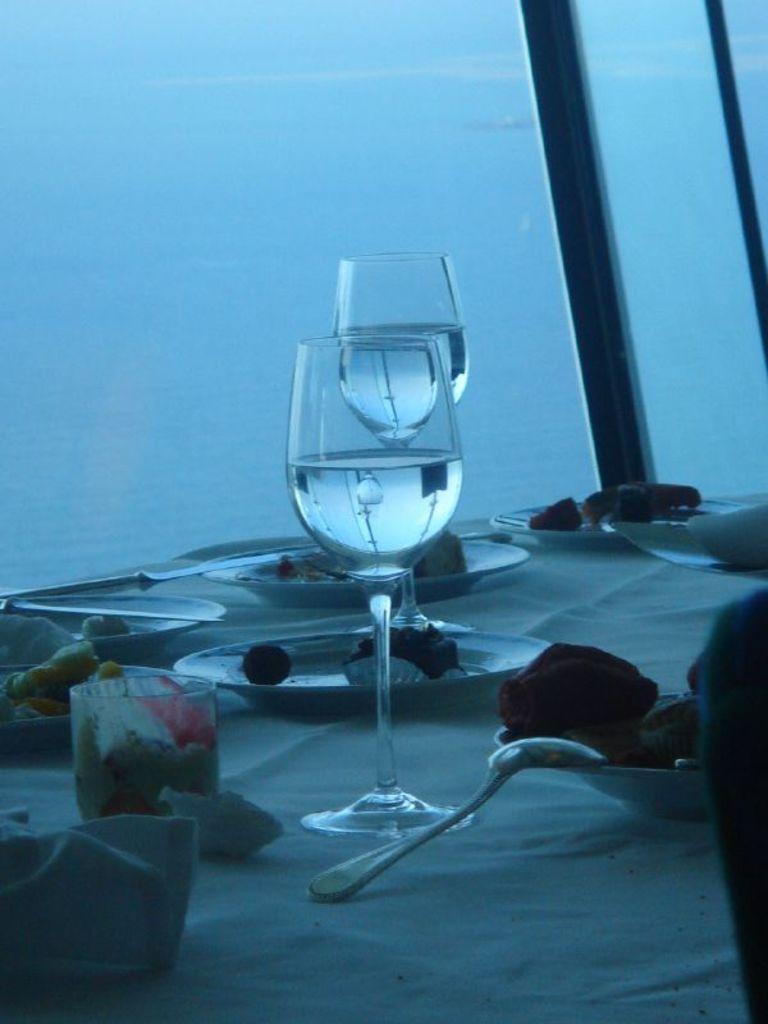Could you give a brief overview of what you see in this image? In this image we can see a table cover with cloth, there are few plates and bowls with food items, there are knives, spoon and there are glasses with water on the table and it looks like an ocean in the background. 